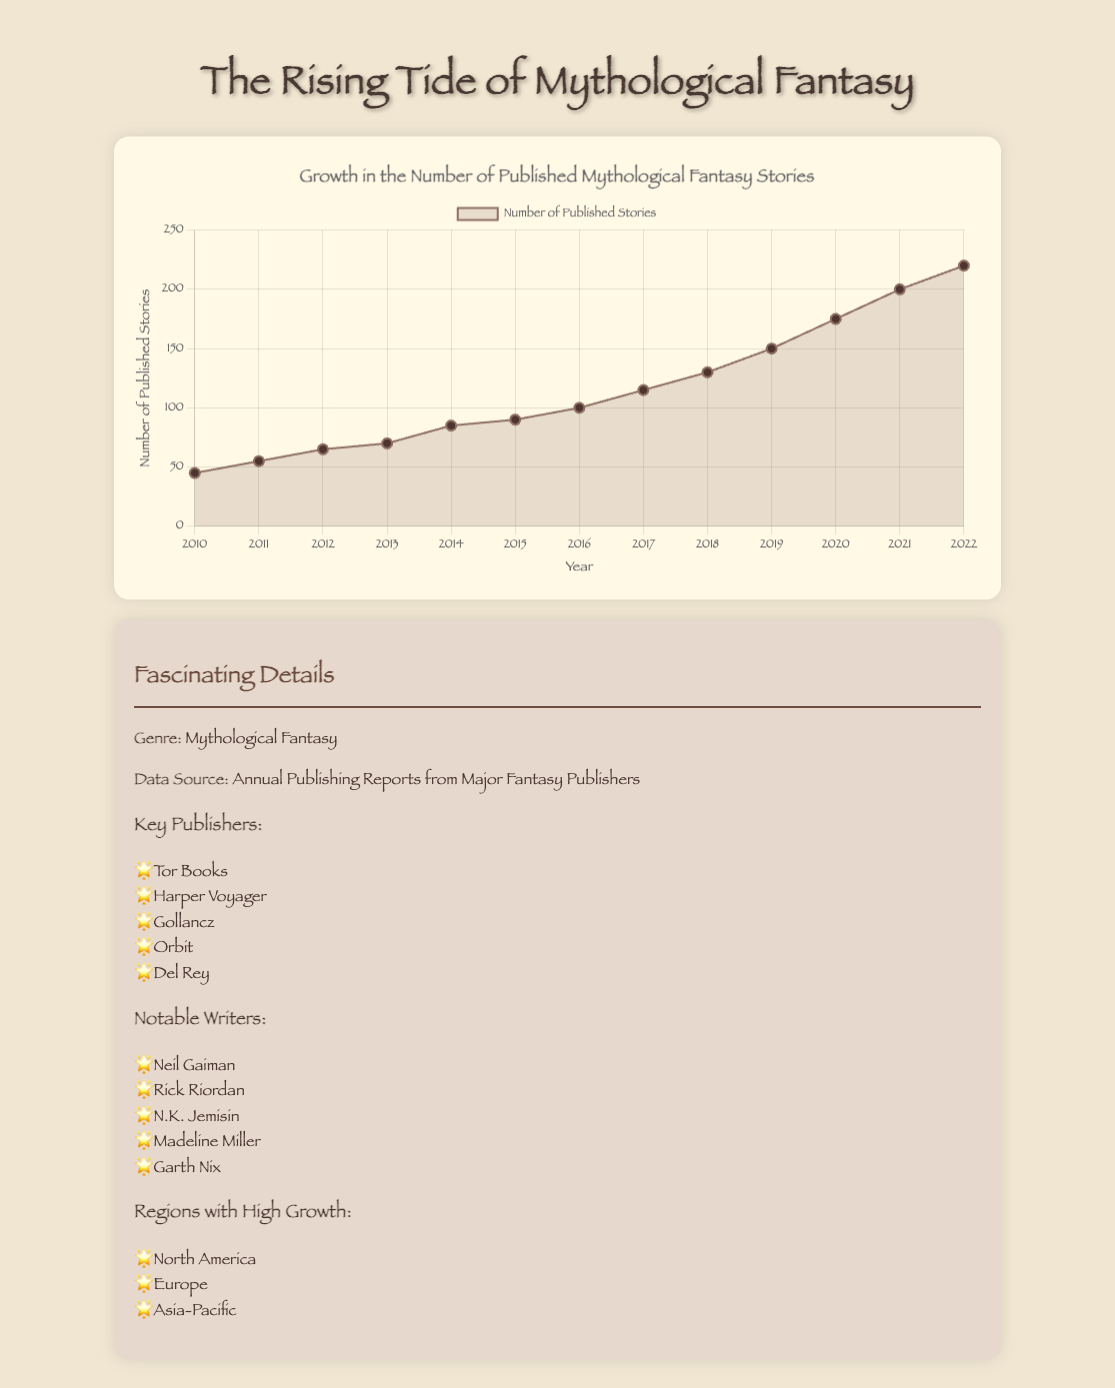What's the total number of stories published from 2010 to 2015? Sum the number of stories published each year from 2010 to 2015: (45 + 55 + 65 + 70 + 85 + 90)
Answer: 410 Which year saw the highest increase in the number of published stories compared to the previous year? Calculate the difference in the number of published stories between consecutive years: (2011-2010: 10, 2012-2011: 10, 2013-2012: 5, 2014-2013: 15, 2015-2014: 5, 2016-2015: 10, 2017-2016: 15, 2018-2017: 15, 2019-2018: 20, 2020-2019: 25, 2021-2020: 25, 2022-2021: 20). The highest increase was in 2020 and 2021 (both had an increase of 25).
Answer: 2020 and 2021 What is the average number of stories published per year over the dataset? Add the total number of stories published from 2010 to 2022 and divide by the number of years: (45+55+65+70+85+90+100+115+130+150+175+200+220)/13
Answer: 112.7 In which year did the number of published stories first exceed 100? Look for the first year in which the number of published stories is greater than 100: The year is 2016 with 100 stories published. The first year the number exceeded 100 is 2017.
Answer: 2017 Compare the growth in the number of published stories between 2010-2015 and 2016-2022. Which period had a higher increase? Calculate the total increase for each period: (2015-2010: 90-45 = 45, 2022-2016: 220-100 = 120). The growth in published stories was higher from 2016 to 2022.
Answer: 2016-2022 Which year had the least number of stories published? Refer to the data to find the year with the lowest number of published stories. The year with the lowest published stories is 2010 with 45 stories.
Answer: 2010 What visual elements are used to differentiate the years on the chart? The chart uses different labels for years on the x-axis with different point markers and line segments for visualization. The color of the line and data points is consistent, making yearly changes visually distinguishable.
Answer: Labels, points, line segments Is there a visible trend in the number of published stories over the years? The plot shows a general upward trend in the number of published mythological fantasy stories from 2010 to 2022, indicating consistent growth in the genre. This upward trend is visible by the increasing values of the line plot over the years.
Answer: Upward trend 